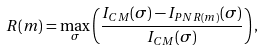<formula> <loc_0><loc_0><loc_500><loc_500>R ( m ) = \max _ { \sigma } \left ( \frac { I _ { C M } ( \sigma ) - I _ { P N R ( m ) } ( \sigma ) } { I _ { C M } ( \sigma ) } \right ) ,</formula> 